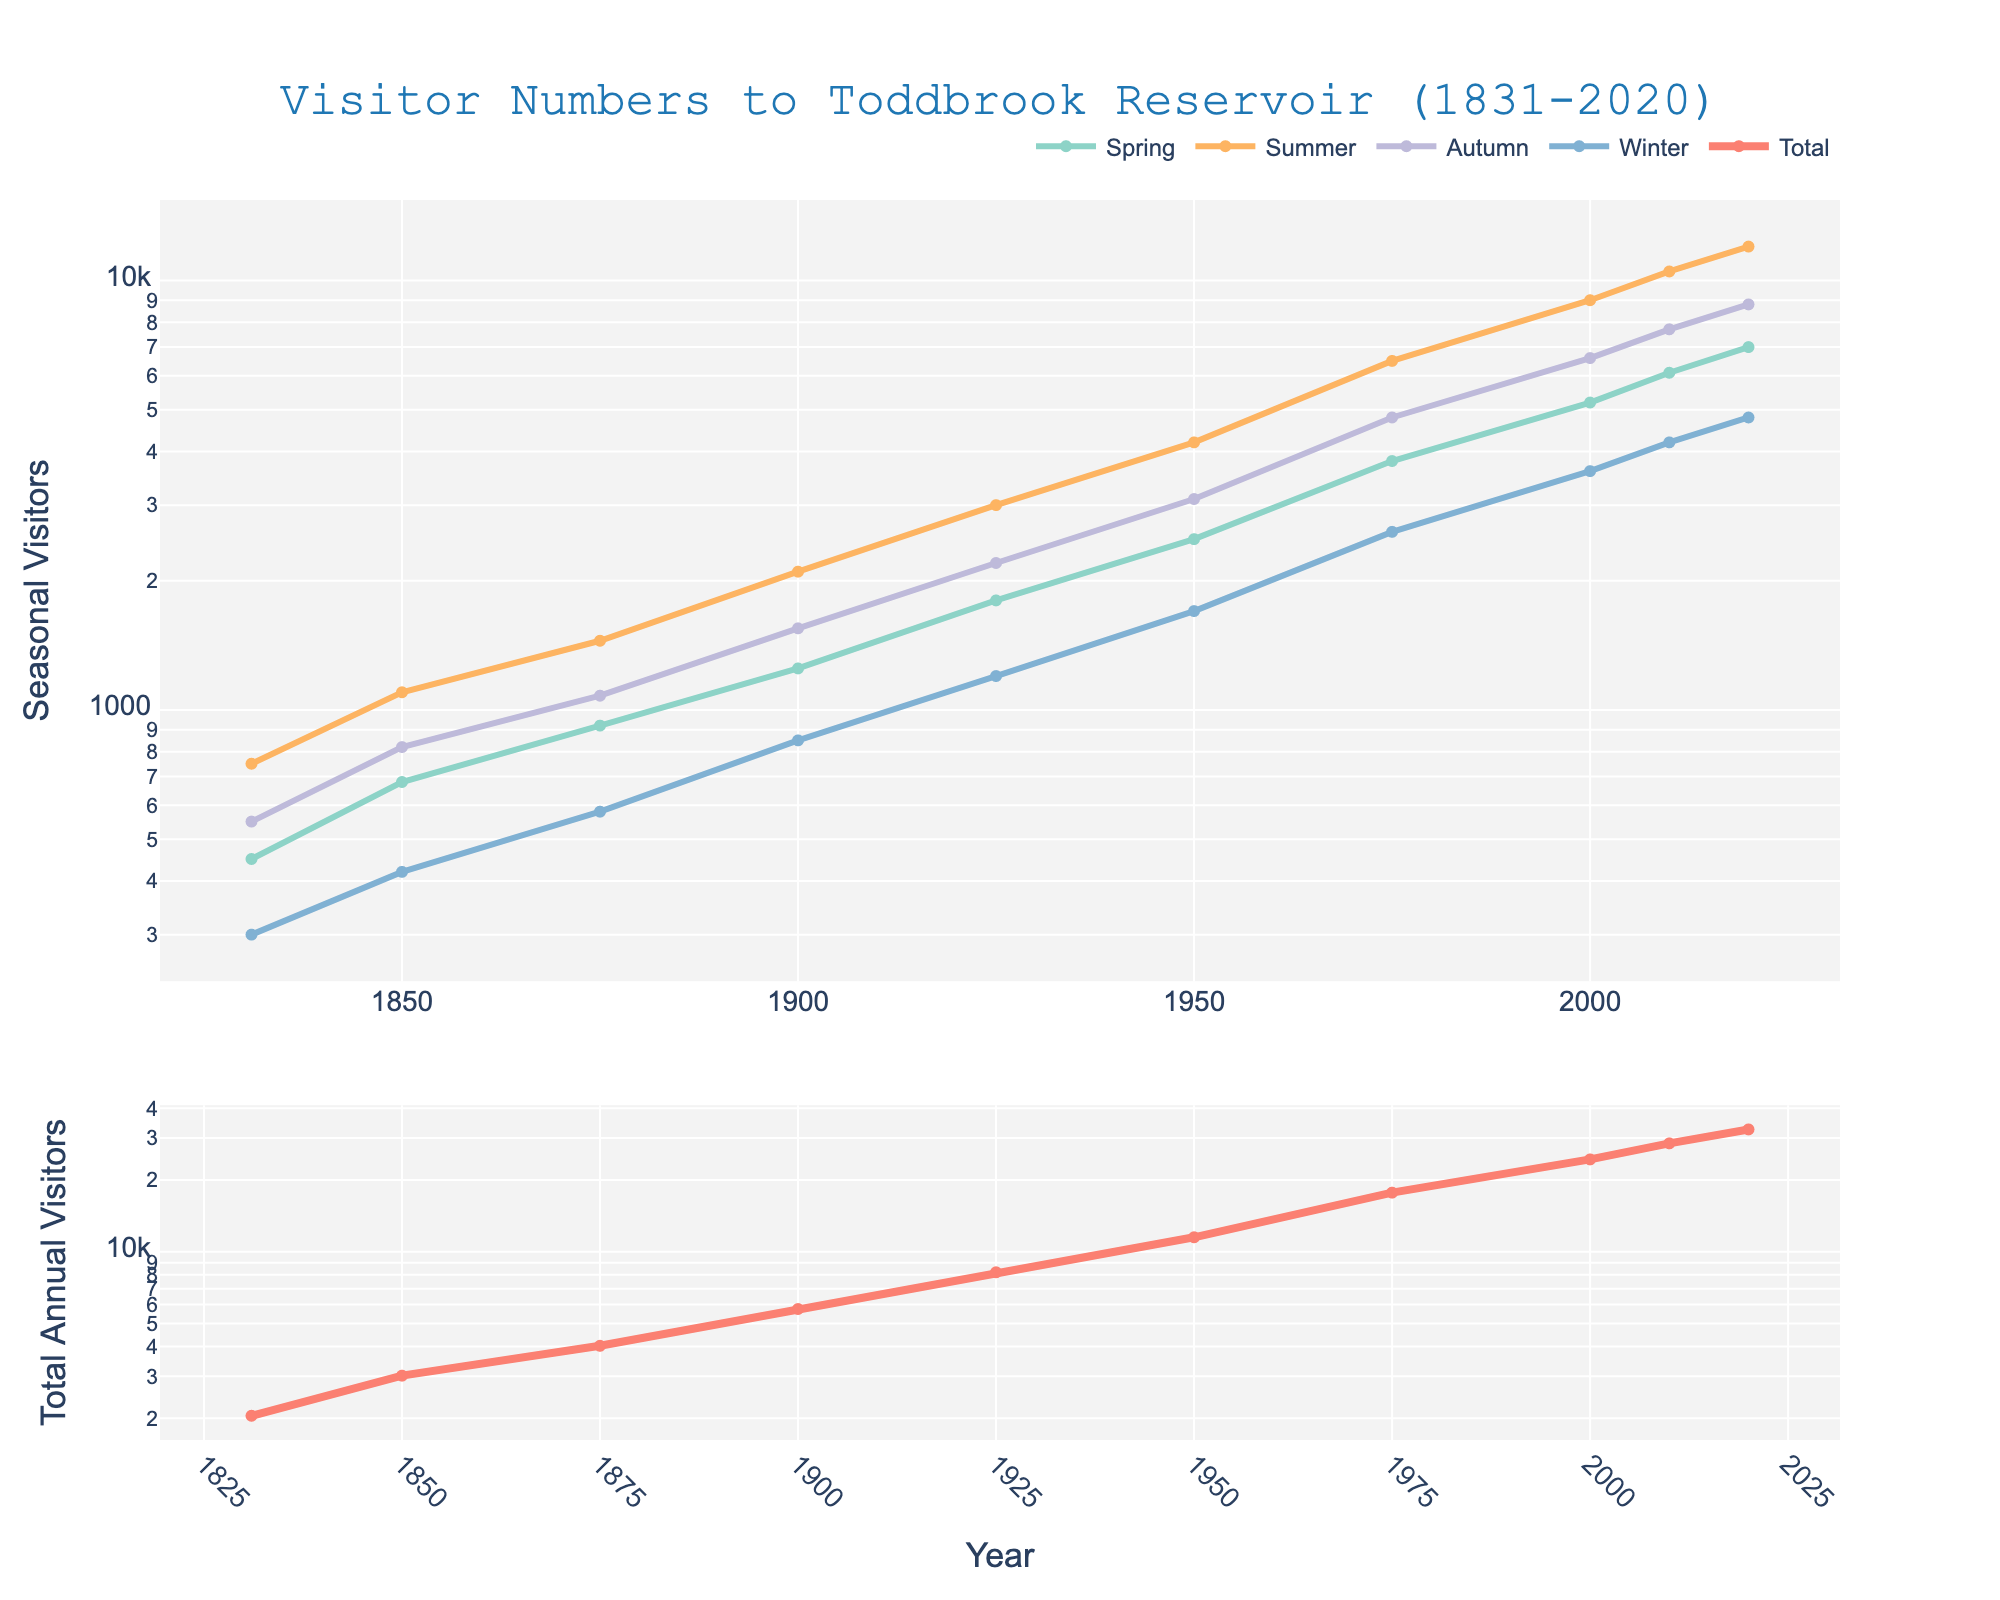What year had the highest number of visitors in summer? Look at the line for the summer season and identify the peak. The highest point in the summer line chart is in the year 2020.
Answer: 2020 In which season did visitor numbers in 1950 surpass 4000? Find the 1950 data point and look at the seasonal lines. In 1950, the summer season has more than 4000 visitors.
Answer: Summer How many total visitors were there in 1925? Look at the total line in the second subplot and find the value at the year 1925. The number reads 8200 visitors.
Answer: 8200 What is the difference in visitor numbers between spring and winter in 2000? Check the values for spring and winter from the year 2000 and calculate the difference. Spring has 5200 visitors and winter has 3600 visitors. So, the difference is 5200 - 3600.
Answer: 1600 What was the general trend of annual visitors between 1831 and 2020? Observe the total line in the second subplot. The trend shows a consistent increase in visitor numbers from 1831 to 2020.
Answer: Increasing Which season consistently had the lowest number of visitors? Compare the lines for all seasons across the years. The winter line is consistently the lowest.
Answer: Winter How did visitor numbers in summer 1900 compare to those in summer 1875? Look at the summer data points for 1900 and 1875. In 1900, summer had 2100 visitors, while in 1875 it had 1450 visitors.
Answer: Summer 1900 had more visitors than summer 1875 Did the number of visitors in autumn exceed 1000 before 1900? Observe the autumn line and check if it crosses above 1000 before the year 1900. The first time it exceeds 1000 is in the year 1900, with 1550 visitors.
Answer: No Which year had an annotation for a specific historical event? Look for any annotations in the chart. There's an annotation for the year 1950 indicating a "Post-war tourism boom."
Answer: 1950 